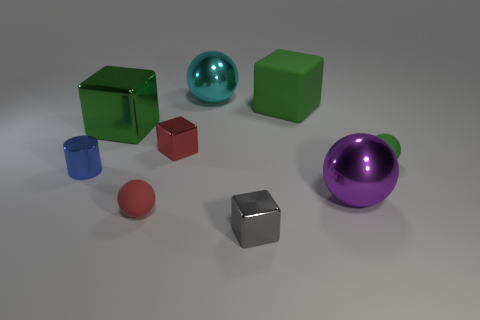What number of metallic spheres are the same color as the matte block?
Provide a short and direct response. 0. There is a tiny red object in front of the tiny red cube that is right of the large green metal cube; what shape is it?
Your answer should be very brief. Sphere. What number of small purple cubes are made of the same material as the small red ball?
Keep it short and to the point. 0. There is a tiny ball that is to the right of the red metallic cube; what material is it?
Provide a succinct answer. Rubber. The metal object that is behind the big green object that is behind the big green thing that is on the left side of the small red matte object is what shape?
Make the answer very short. Sphere. There is a small matte object behind the tiny blue shiny thing; is its color the same as the big block behind the large green metal cube?
Make the answer very short. Yes. Is the number of matte cubes right of the green matte cube less than the number of small shiny things that are behind the big purple object?
Give a very brief answer. Yes. Are there any other things that are the same shape as the small blue object?
Ensure brevity in your answer.  No. What color is the other large metal object that is the same shape as the purple object?
Provide a short and direct response. Cyan. There is a small red metallic object; is it the same shape as the small shiny object that is in front of the purple sphere?
Make the answer very short. Yes. 